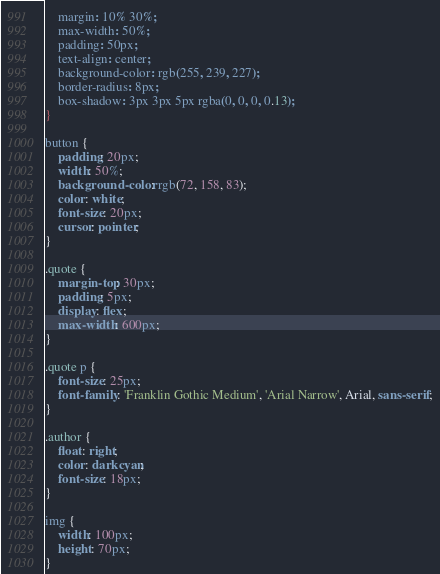<code> <loc_0><loc_0><loc_500><loc_500><_CSS_>    margin: 10% 30%;
    max-width: 50%;
    padding: 50px;
    text-align: center;
    background-color: rgb(255, 239, 227);
    border-radius: 8px;
    box-shadow: 3px 3px 5px rgba(0, 0, 0, 0.13);
}

button {
    padding: 20px;
    width: 50%;
    background-color: rgb(72, 158, 83);
    color: white;
    font-size: 20px;
    cursor: pointer;
}

.quote {
    margin-top: 30px;
    padding: 5px;
    display: flex;
    max-width: 600px;
}

.quote p {
    font-size: 25px;
    font-family: 'Franklin Gothic Medium', 'Arial Narrow', Arial, sans-serif;
}

.author {
    float: right;
    color: darkcyan;
    font-size: 18px;
}

img {
    width: 100px;
    height: 70px;
}</code> 